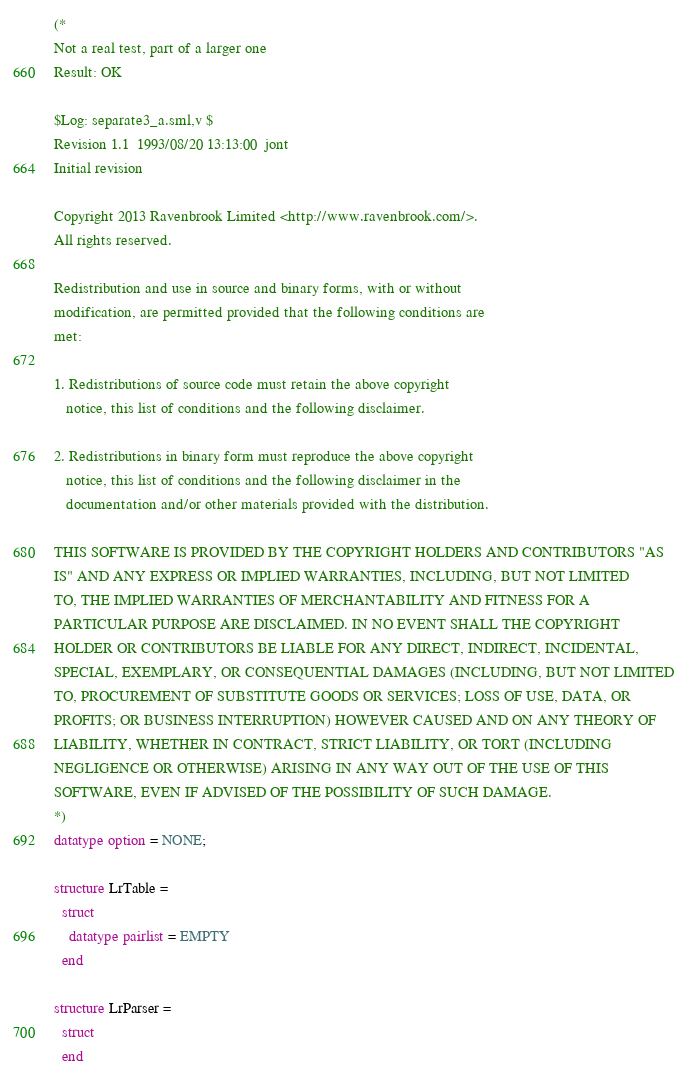<code> <loc_0><loc_0><loc_500><loc_500><_SML_>(*
Not a real test, part of a larger one
Result: OK
 
$Log: separate3_a.sml,v $
Revision 1.1  1993/08/20 13:13:00  jont
Initial revision

Copyright 2013 Ravenbrook Limited <http://www.ravenbrook.com/>.
All rights reserved.

Redistribution and use in source and binary forms, with or without
modification, are permitted provided that the following conditions are
met:

1. Redistributions of source code must retain the above copyright
   notice, this list of conditions and the following disclaimer.

2. Redistributions in binary form must reproduce the above copyright
   notice, this list of conditions and the following disclaimer in the
   documentation and/or other materials provided with the distribution.

THIS SOFTWARE IS PROVIDED BY THE COPYRIGHT HOLDERS AND CONTRIBUTORS "AS
IS" AND ANY EXPRESS OR IMPLIED WARRANTIES, INCLUDING, BUT NOT LIMITED
TO, THE IMPLIED WARRANTIES OF MERCHANTABILITY AND FITNESS FOR A
PARTICULAR PURPOSE ARE DISCLAIMED. IN NO EVENT SHALL THE COPYRIGHT
HOLDER OR CONTRIBUTORS BE LIABLE FOR ANY DIRECT, INDIRECT, INCIDENTAL,
SPECIAL, EXEMPLARY, OR CONSEQUENTIAL DAMAGES (INCLUDING, BUT NOT LIMITED
TO, PROCUREMENT OF SUBSTITUTE GOODS OR SERVICES; LOSS OF USE, DATA, OR
PROFITS; OR BUSINESS INTERRUPTION) HOWEVER CAUSED AND ON ANY THEORY OF
LIABILITY, WHETHER IN CONTRACT, STRICT LIABILITY, OR TORT (INCLUDING
NEGLIGENCE OR OTHERWISE) ARISING IN ANY WAY OUT OF THE USE OF THIS
SOFTWARE, EVEN IF ADVISED OF THE POSSIBILITY OF SUCH DAMAGE.
*)
datatype option = NONE;

structure LrTable = 
  struct
    datatype pairlist = EMPTY
  end

structure LrParser =
  struct
  end
</code> 